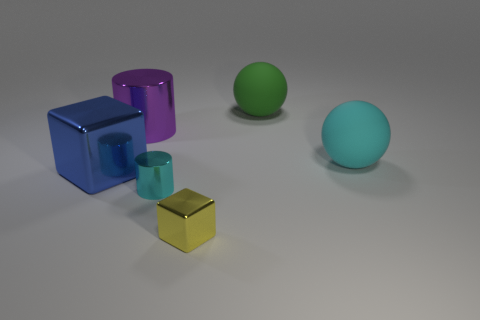Add 2 yellow metallic cubes. How many objects exist? 8 Subtract all cubes. How many objects are left? 4 Subtract 0 brown cubes. How many objects are left? 6 Subtract all green balls. Subtract all purple shiny things. How many objects are left? 4 Add 3 cylinders. How many cylinders are left? 5 Add 1 large rubber objects. How many large rubber objects exist? 3 